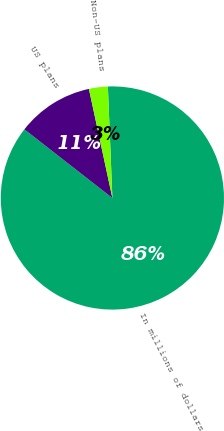Convert chart. <chart><loc_0><loc_0><loc_500><loc_500><pie_chart><fcel>In millions of dollars<fcel>US plans<fcel>Non-US plans<nl><fcel>86.19%<fcel>11.08%<fcel>2.73%<nl></chart> 